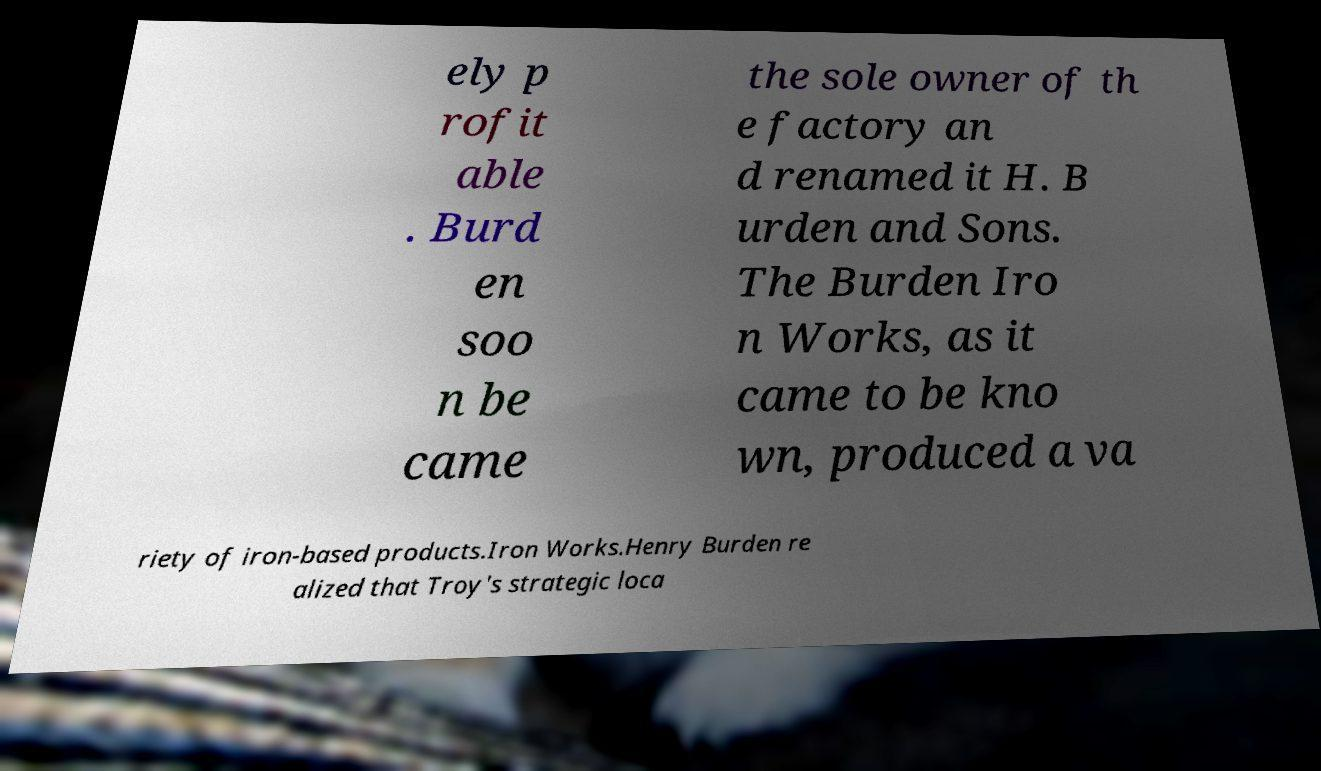Please read and relay the text visible in this image. What does it say? ely p rofit able . Burd en soo n be came the sole owner of th e factory an d renamed it H. B urden and Sons. The Burden Iro n Works, as it came to be kno wn, produced a va riety of iron-based products.Iron Works.Henry Burden re alized that Troy's strategic loca 